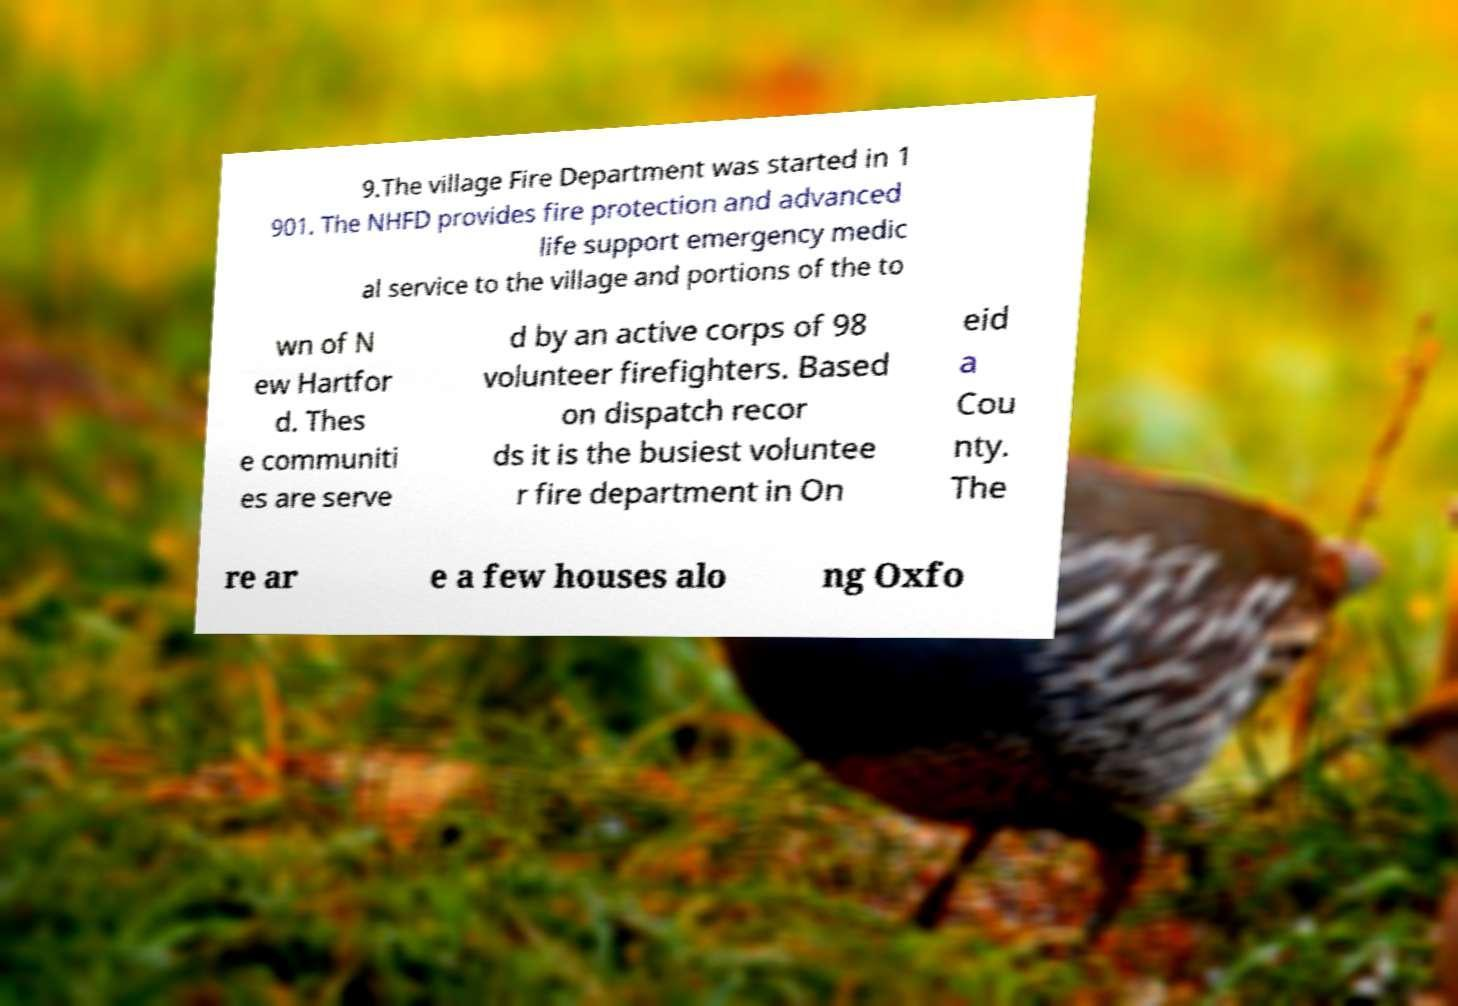Could you assist in decoding the text presented in this image and type it out clearly? 9.The village Fire Department was started in 1 901. The NHFD provides fire protection and advanced life support emergency medic al service to the village and portions of the to wn of N ew Hartfor d. Thes e communiti es are serve d by an active corps of 98 volunteer firefighters. Based on dispatch recor ds it is the busiest voluntee r fire department in On eid a Cou nty. The re ar e a few houses alo ng Oxfo 